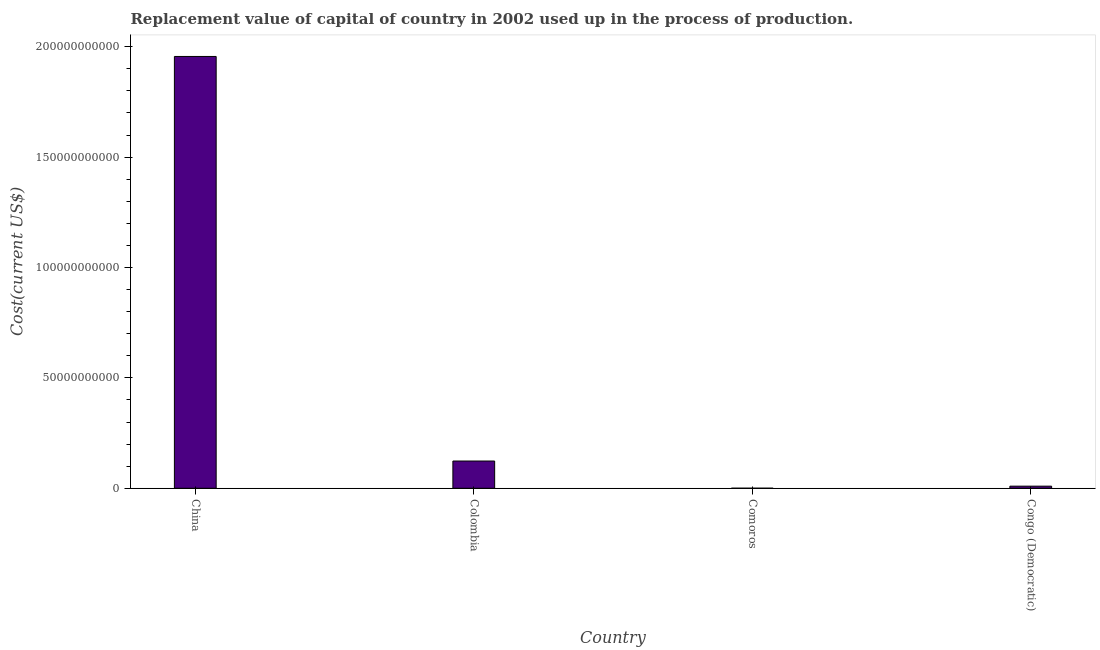Does the graph contain grids?
Offer a terse response. No. What is the title of the graph?
Provide a succinct answer. Replacement value of capital of country in 2002 used up in the process of production. What is the label or title of the Y-axis?
Keep it short and to the point. Cost(current US$). What is the consumption of fixed capital in Congo (Democratic)?
Provide a succinct answer. 9.57e+08. Across all countries, what is the maximum consumption of fixed capital?
Give a very brief answer. 1.96e+11. Across all countries, what is the minimum consumption of fixed capital?
Your answer should be very brief. 3.43e+07. In which country was the consumption of fixed capital maximum?
Keep it short and to the point. China. In which country was the consumption of fixed capital minimum?
Make the answer very short. Comoros. What is the sum of the consumption of fixed capital?
Give a very brief answer. 2.09e+11. What is the difference between the consumption of fixed capital in China and Congo (Democratic)?
Provide a short and direct response. 1.95e+11. What is the average consumption of fixed capital per country?
Provide a succinct answer. 5.22e+1. What is the median consumption of fixed capital?
Your answer should be very brief. 6.65e+09. What is the ratio of the consumption of fixed capital in Comoros to that in Congo (Democratic)?
Keep it short and to the point. 0.04. What is the difference between the highest and the second highest consumption of fixed capital?
Give a very brief answer. 1.83e+11. Is the sum of the consumption of fixed capital in Comoros and Congo (Democratic) greater than the maximum consumption of fixed capital across all countries?
Your answer should be compact. No. What is the difference between the highest and the lowest consumption of fixed capital?
Ensure brevity in your answer.  1.96e+11. How many countries are there in the graph?
Your answer should be compact. 4. What is the Cost(current US$) of China?
Give a very brief answer. 1.96e+11. What is the Cost(current US$) of Colombia?
Keep it short and to the point. 1.23e+1. What is the Cost(current US$) in Comoros?
Keep it short and to the point. 3.43e+07. What is the Cost(current US$) in Congo (Democratic)?
Your answer should be very brief. 9.57e+08. What is the difference between the Cost(current US$) in China and Colombia?
Provide a succinct answer. 1.83e+11. What is the difference between the Cost(current US$) in China and Comoros?
Ensure brevity in your answer.  1.96e+11. What is the difference between the Cost(current US$) in China and Congo (Democratic)?
Ensure brevity in your answer.  1.95e+11. What is the difference between the Cost(current US$) in Colombia and Comoros?
Offer a terse response. 1.23e+1. What is the difference between the Cost(current US$) in Colombia and Congo (Democratic)?
Offer a terse response. 1.14e+1. What is the difference between the Cost(current US$) in Comoros and Congo (Democratic)?
Offer a very short reply. -9.22e+08. What is the ratio of the Cost(current US$) in China to that in Colombia?
Make the answer very short. 15.84. What is the ratio of the Cost(current US$) in China to that in Comoros?
Ensure brevity in your answer.  5709.93. What is the ratio of the Cost(current US$) in China to that in Congo (Democratic)?
Offer a very short reply. 204.47. What is the ratio of the Cost(current US$) in Colombia to that in Comoros?
Provide a succinct answer. 360.51. What is the ratio of the Cost(current US$) in Colombia to that in Congo (Democratic)?
Provide a short and direct response. 12.91. What is the ratio of the Cost(current US$) in Comoros to that in Congo (Democratic)?
Your response must be concise. 0.04. 